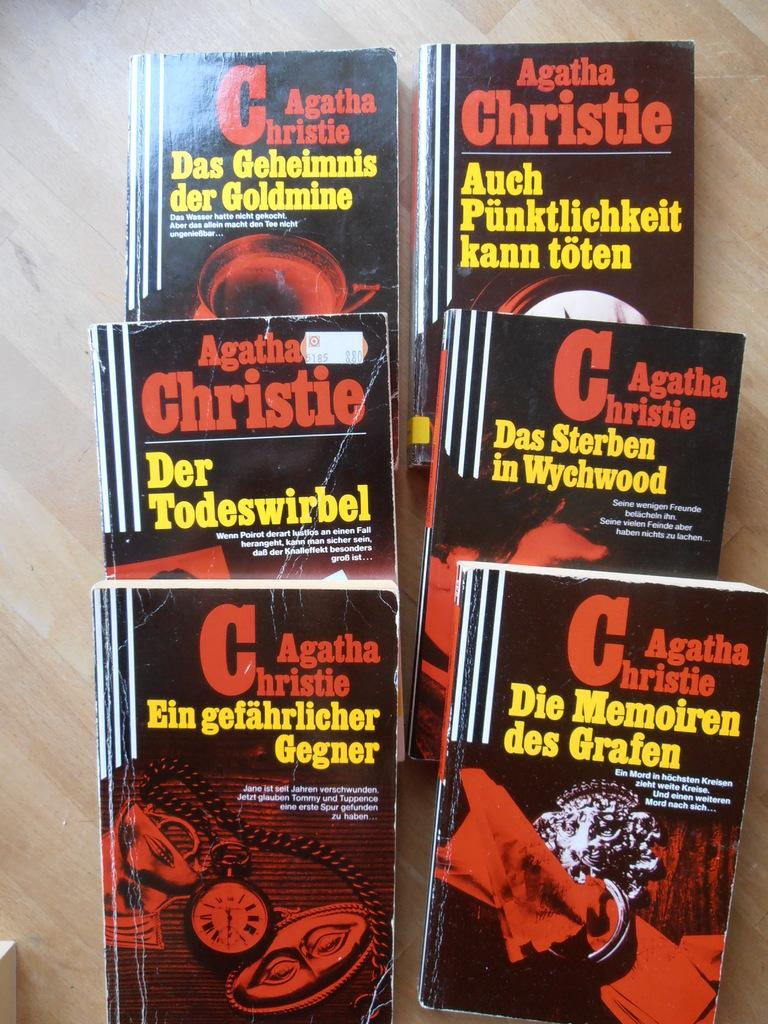<image>
Render a clear and concise summary of the photo. A collection of Agatha Christie novels are lying on a table. 